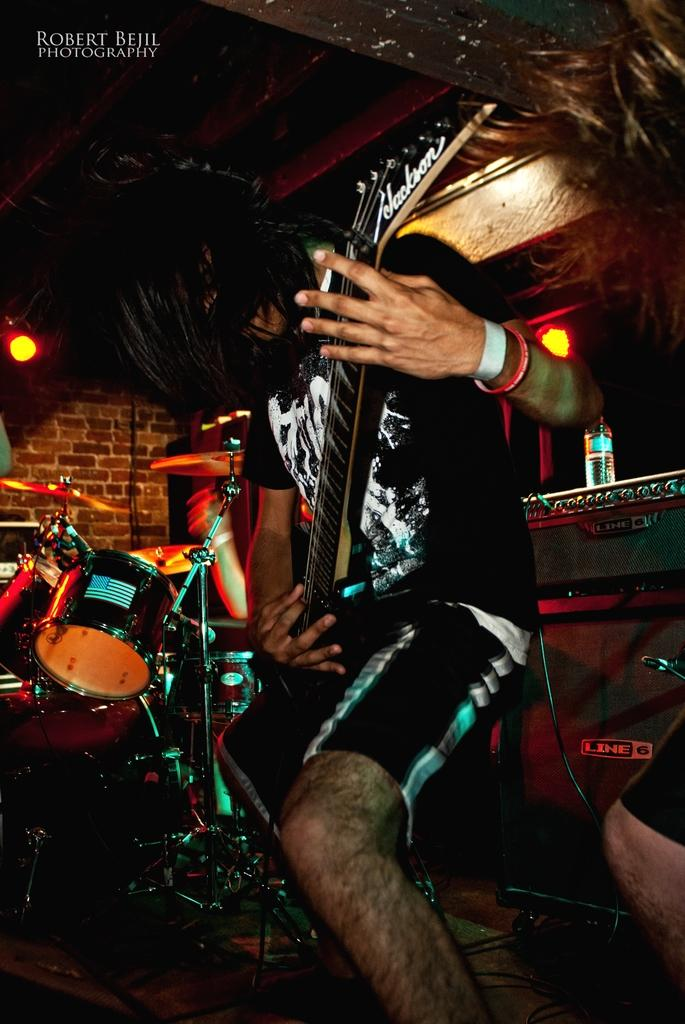What is the main subject of the image? There is a man in the image. What is the man wearing? The man is wearing a black t-shirt. What is the man doing in the image? The man is playing a guitar. What other musical instrument can be seen in the image? There are drums in the image. What type of background is present in the image? There is a brick wall in the image. What can be seen providing light in the image? There is a light in the image. What type of knee injury is the man suffering from in the image? There is no indication of a knee injury in the image; the man is playing a guitar and appears to be in good health. 